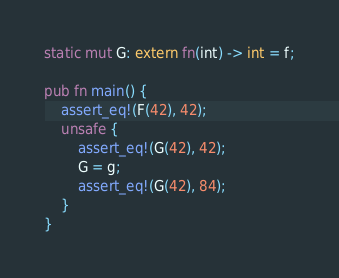<code> <loc_0><loc_0><loc_500><loc_500><_Rust_>static mut G: extern fn(int) -> int = f;

pub fn main() {
    assert_eq!(F(42), 42);
    unsafe {
        assert_eq!(G(42), 42);
        G = g;
        assert_eq!(G(42), 84);
    }
}
</code> 